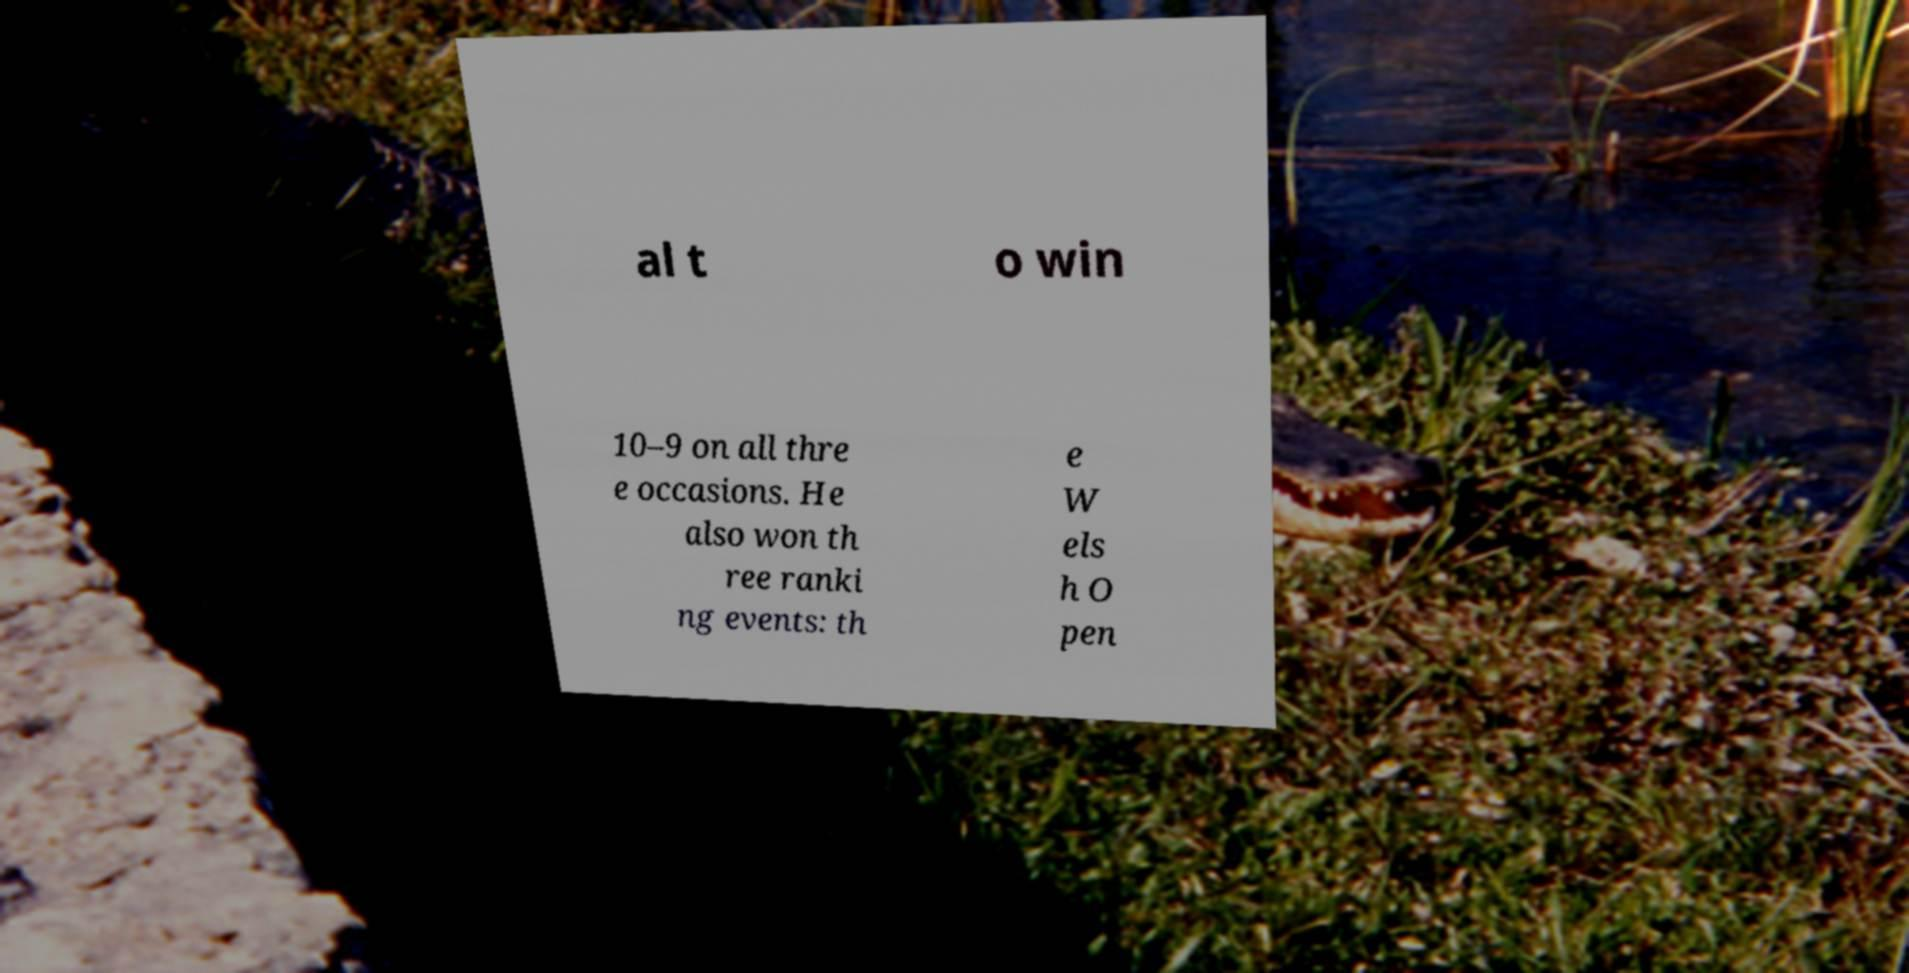Can you read and provide the text displayed in the image?This photo seems to have some interesting text. Can you extract and type it out for me? al t o win 10–9 on all thre e occasions. He also won th ree ranki ng events: th e W els h O pen 